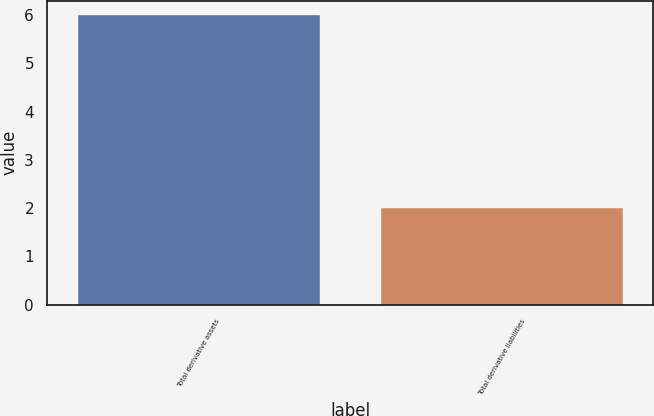Convert chart to OTSL. <chart><loc_0><loc_0><loc_500><loc_500><bar_chart><fcel>Total derivative assets<fcel>Total derivative liabilities<nl><fcel>6<fcel>2<nl></chart> 